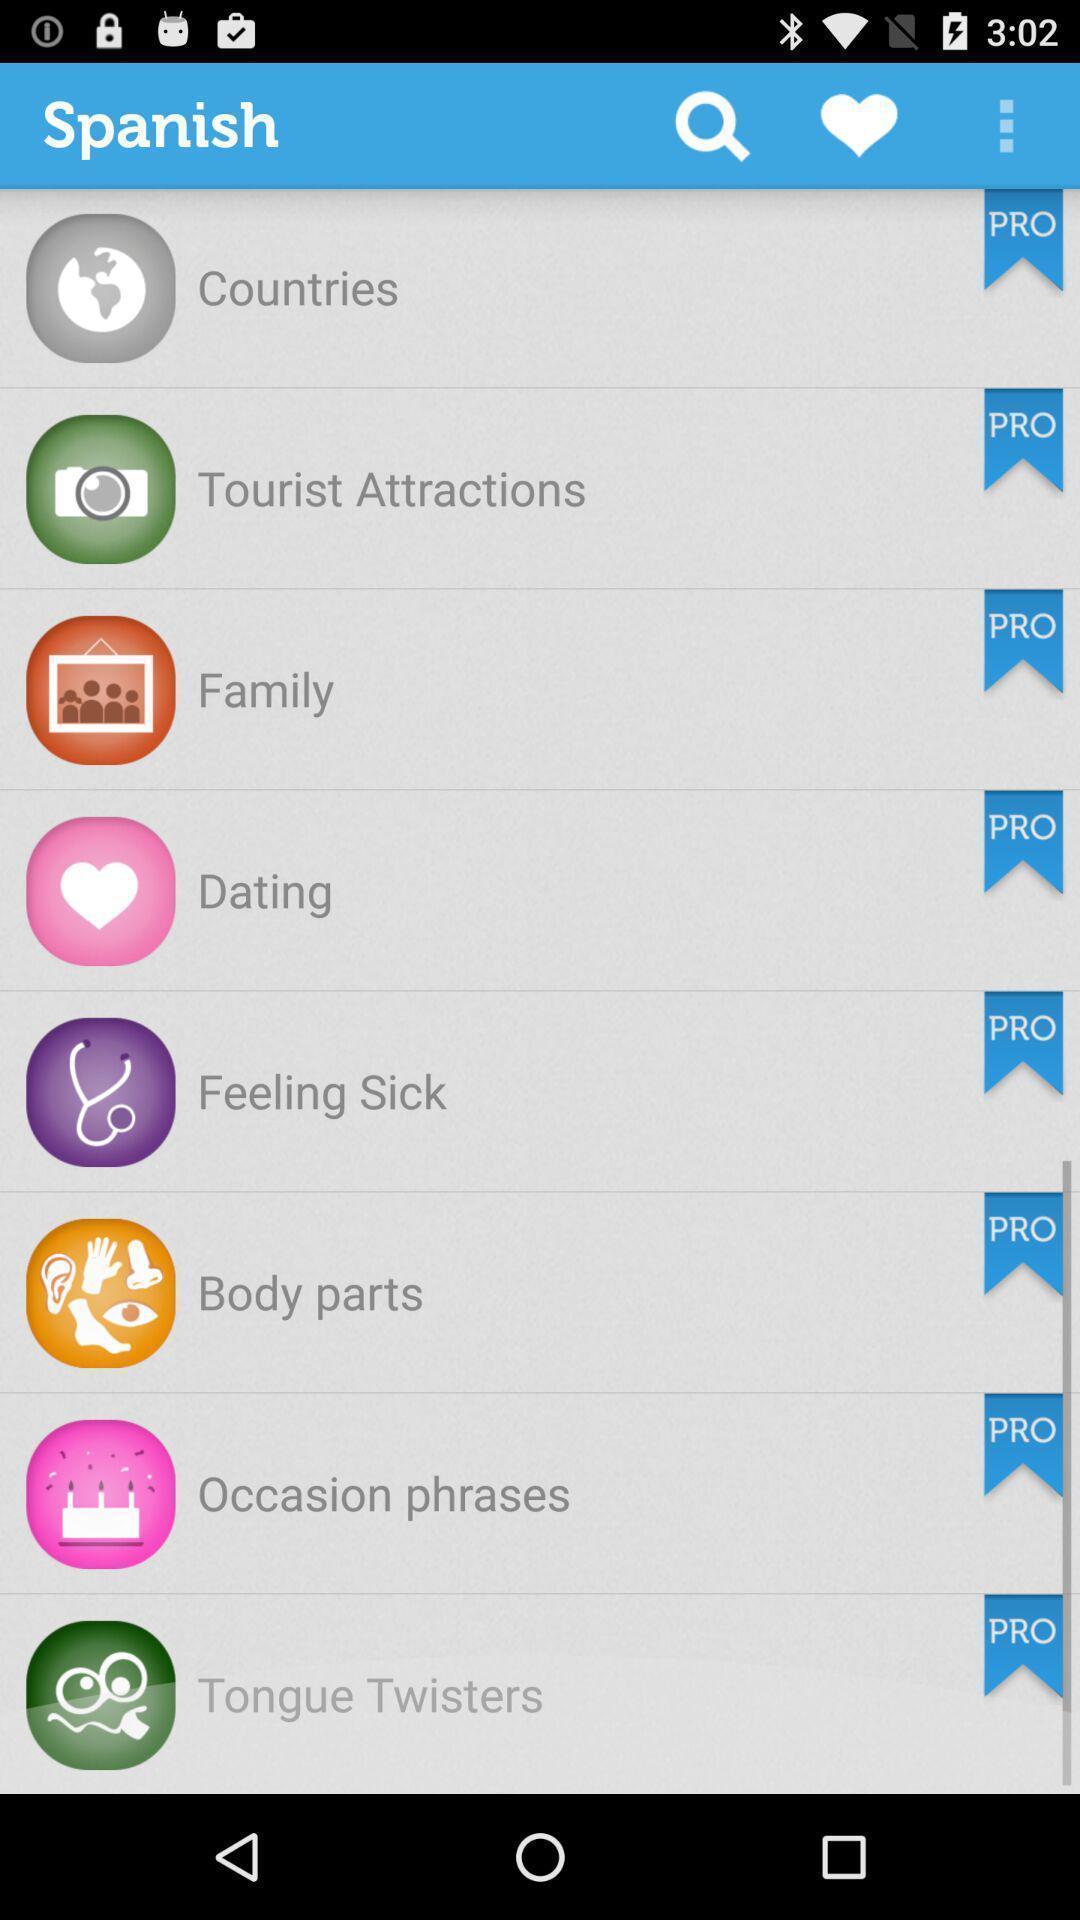Tell me about the visual elements in this screen capture. Menu options for the language learning app. 